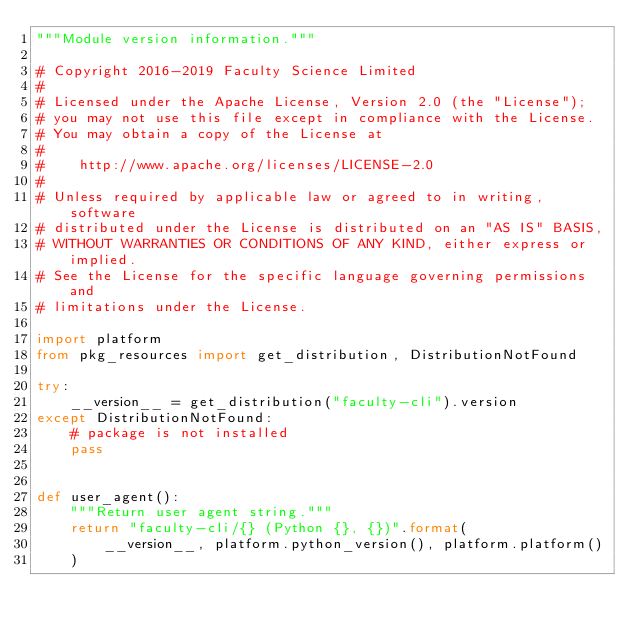<code> <loc_0><loc_0><loc_500><loc_500><_Python_>"""Module version information."""

# Copyright 2016-2019 Faculty Science Limited
#
# Licensed under the Apache License, Version 2.0 (the "License");
# you may not use this file except in compliance with the License.
# You may obtain a copy of the License at
#
#    http://www.apache.org/licenses/LICENSE-2.0
#
# Unless required by applicable law or agreed to in writing, software
# distributed under the License is distributed on an "AS IS" BASIS,
# WITHOUT WARRANTIES OR CONDITIONS OF ANY KIND, either express or implied.
# See the License for the specific language governing permissions and
# limitations under the License.

import platform
from pkg_resources import get_distribution, DistributionNotFound

try:
    __version__ = get_distribution("faculty-cli").version
except DistributionNotFound:
    # package is not installed
    pass


def user_agent():
    """Return user agent string."""
    return "faculty-cli/{} (Python {}, {})".format(
        __version__, platform.python_version(), platform.platform()
    )
</code> 